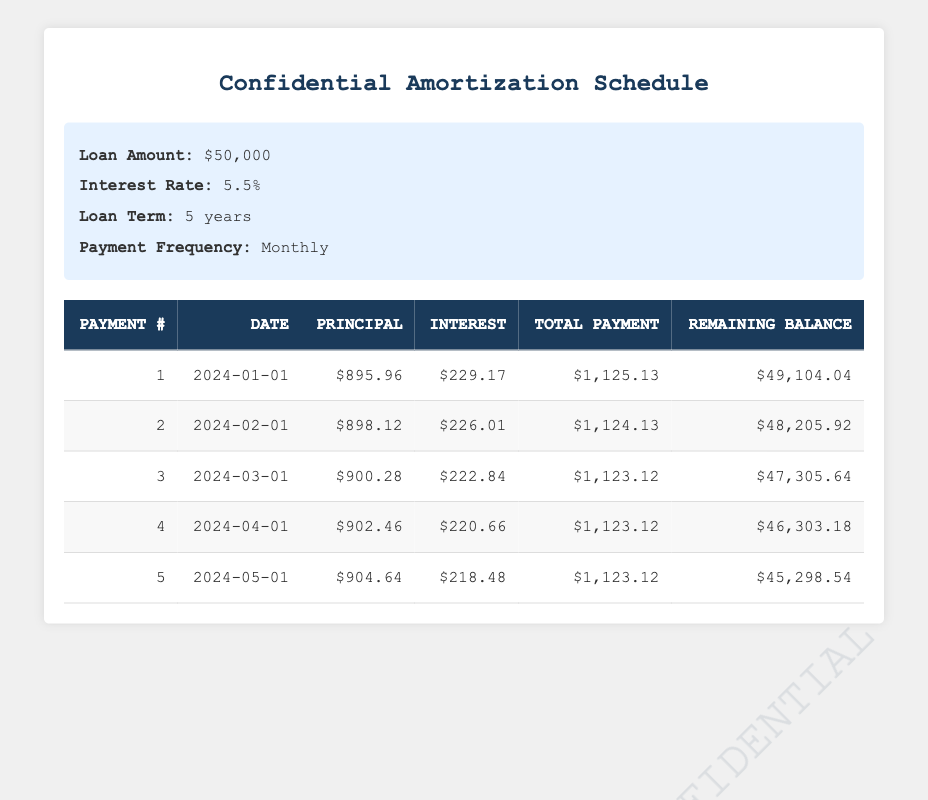What is the total payment for the first month? The total payment for the first month is listed in the row for payment number 1 under the "Total Payment" column. It shows $1,125.13.
Answer: 1125.13 What is the interest payment in the second month? The interest payment for the second month can be found in the row for payment number 2 under the "Interest" column. It shows $226.01.
Answer: 226.01 What is the principal payment for the third month? The principal payment for the third month is in the row for payment number 3 under the "Principal" column, which shows $900.28.
Answer: 900.28 How much total interest will be paid in the first five payments? To find the total interest paid in the first five payments, we sum the interest payments from each month: 229.17 + 226.01 + 222.84 + 220.66 + 218.48 = 1,116.16.
Answer: 1116.16 Is the remaining balance after the fifth month less than $45,000? The remaining balance after the fifth month is $45,298.54 from the "Remaining Balance" column for payment number 5. Since $45,298.54 is greater than $45,000, the answer is no.
Answer: No What is the average principal payment over the first five payments? To calculate the average principal payment, sum the principal payments for the first five months: 895.96 + 898.12 + 900.28 + 902.46 + 904.64 = 4,501.46. Then divide by 5 (4,501.46 / 5) to get an average of approximately $900.29.
Answer: 900.29 What is the difference between the total payment of the first month and the total payment of the last month? The total payment for the first month is $1,125.13 and for the fifth month, it is $1,123.12. The difference is calculated as $1,125.13 - $1,123.12, which equals $2.01.
Answer: 2.01 How much principal is paid off in total after four months? To find the total principal paid off after four months, sum the principal payments from the first four months: 895.96 + 898.12 + 900.28 + 902.46 = 3,596.82.
Answer: 3596.82 Is the total monthly payment consistent throughout the first five payments? Reviewing the "Total Payment" column, we observe that the total payment fluctuates slightly, with the totals being $1,125.13, $1,124.13, $1,123.12, $1,123.12, and $1,123.12, thus making it inconsistent.
Answer: Yes 